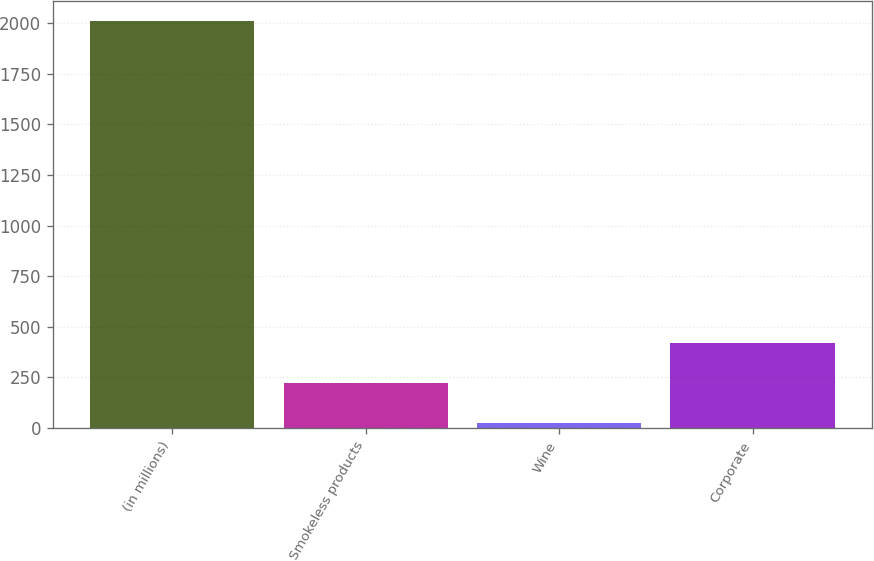Convert chart to OTSL. <chart><loc_0><loc_0><loc_500><loc_500><bar_chart><fcel>(in millions)<fcel>Smokeless products<fcel>Wine<fcel>Corporate<nl><fcel>2010<fcel>221.7<fcel>23<fcel>420.4<nl></chart> 